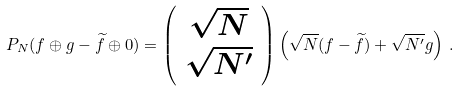<formula> <loc_0><loc_0><loc_500><loc_500>P _ { N } ( f \oplus g - \widetilde { f } \oplus 0 ) = \left ( \begin{array} { c } \sqrt { N } \\ \sqrt { N ^ { \prime } } \end{array} \right ) \left ( \sqrt { N } ( f - \widetilde { f } ) + \sqrt { N ^ { \prime } } g \right ) \, .</formula> 